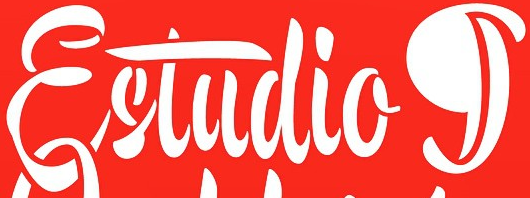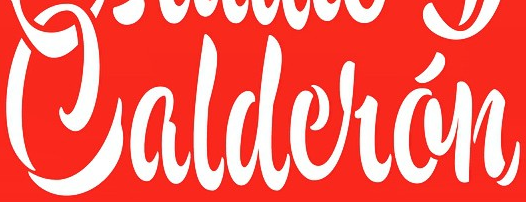What text is displayed in these images sequentially, separated by a semicolon? Estudiog; Caldelán 